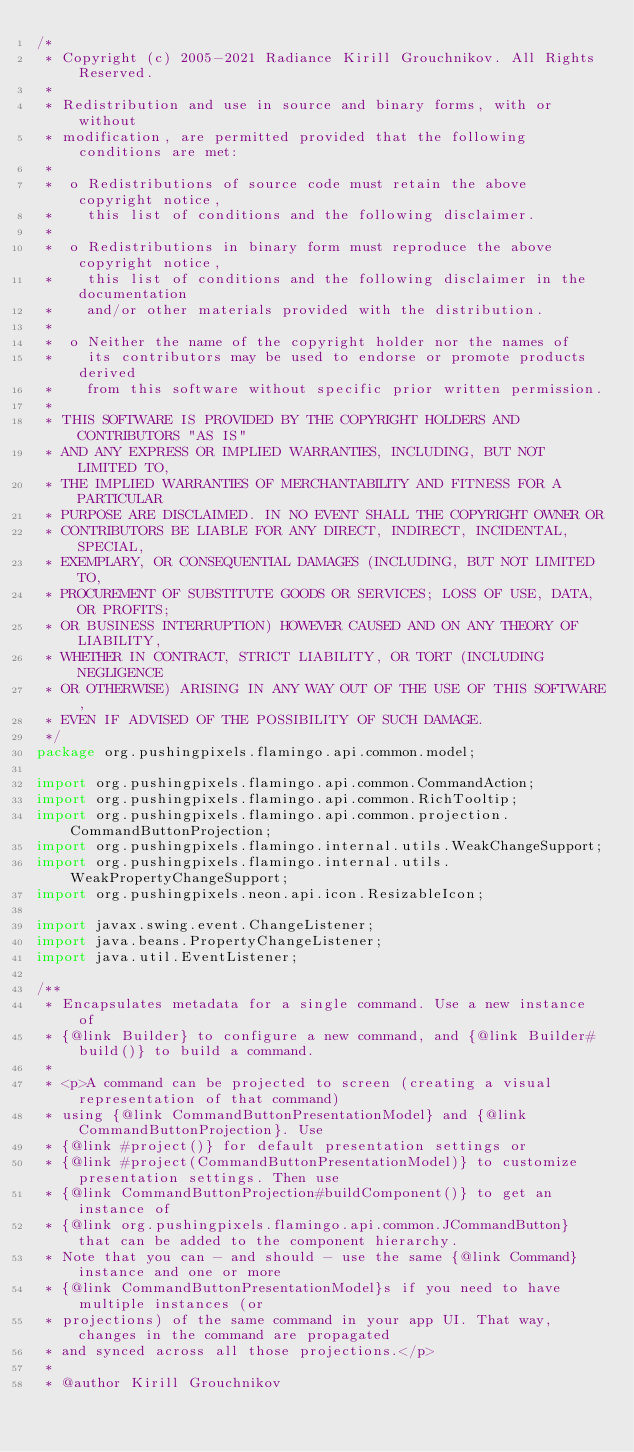Convert code to text. <code><loc_0><loc_0><loc_500><loc_500><_Java_>/*
 * Copyright (c) 2005-2021 Radiance Kirill Grouchnikov. All Rights Reserved.
 *
 * Redistribution and use in source and binary forms, with or without
 * modification, are permitted provided that the following conditions are met:
 *
 *  o Redistributions of source code must retain the above copyright notice,
 *    this list of conditions and the following disclaimer.
 *
 *  o Redistributions in binary form must reproduce the above copyright notice,
 *    this list of conditions and the following disclaimer in the documentation
 *    and/or other materials provided with the distribution.
 *
 *  o Neither the name of the copyright holder nor the names of
 *    its contributors may be used to endorse or promote products derived
 *    from this software without specific prior written permission.
 *
 * THIS SOFTWARE IS PROVIDED BY THE COPYRIGHT HOLDERS AND CONTRIBUTORS "AS IS"
 * AND ANY EXPRESS OR IMPLIED WARRANTIES, INCLUDING, BUT NOT LIMITED TO,
 * THE IMPLIED WARRANTIES OF MERCHANTABILITY AND FITNESS FOR A PARTICULAR
 * PURPOSE ARE DISCLAIMED. IN NO EVENT SHALL THE COPYRIGHT OWNER OR
 * CONTRIBUTORS BE LIABLE FOR ANY DIRECT, INDIRECT, INCIDENTAL, SPECIAL,
 * EXEMPLARY, OR CONSEQUENTIAL DAMAGES (INCLUDING, BUT NOT LIMITED TO,
 * PROCUREMENT OF SUBSTITUTE GOODS OR SERVICES; LOSS OF USE, DATA, OR PROFITS;
 * OR BUSINESS INTERRUPTION) HOWEVER CAUSED AND ON ANY THEORY OF LIABILITY,
 * WHETHER IN CONTRACT, STRICT LIABILITY, OR TORT (INCLUDING NEGLIGENCE
 * OR OTHERWISE) ARISING IN ANY WAY OUT OF THE USE OF THIS SOFTWARE,
 * EVEN IF ADVISED OF THE POSSIBILITY OF SUCH DAMAGE.
 */
package org.pushingpixels.flamingo.api.common.model;

import org.pushingpixels.flamingo.api.common.CommandAction;
import org.pushingpixels.flamingo.api.common.RichTooltip;
import org.pushingpixels.flamingo.api.common.projection.CommandButtonProjection;
import org.pushingpixels.flamingo.internal.utils.WeakChangeSupport;
import org.pushingpixels.flamingo.internal.utils.WeakPropertyChangeSupport;
import org.pushingpixels.neon.api.icon.ResizableIcon;

import javax.swing.event.ChangeListener;
import java.beans.PropertyChangeListener;
import java.util.EventListener;

/**
 * Encapsulates metadata for a single command. Use a new instance of
 * {@link Builder} to configure a new command, and {@link Builder#build()} to build a command.
 *
 * <p>A command can be projected to screen (creating a visual representation of that command)
 * using {@link CommandButtonPresentationModel} and {@link CommandButtonProjection}. Use
 * {@link #project()} for default presentation settings or
 * {@link #project(CommandButtonPresentationModel)} to customize presentation settings. Then use
 * {@link CommandButtonProjection#buildComponent()} to get an instance of
 * {@link org.pushingpixels.flamingo.api.common.JCommandButton} that can be added to the component hierarchy.
 * Note that you can - and should - use the same {@link Command} instance and one or more
 * {@link CommandButtonPresentationModel}s if you need to have multiple instances (or
 * projections) of the same command in your app UI. That way, changes in the command are propagated
 * and synced across all those projections.</p>
 *
 * @author Kirill Grouchnikov</code> 